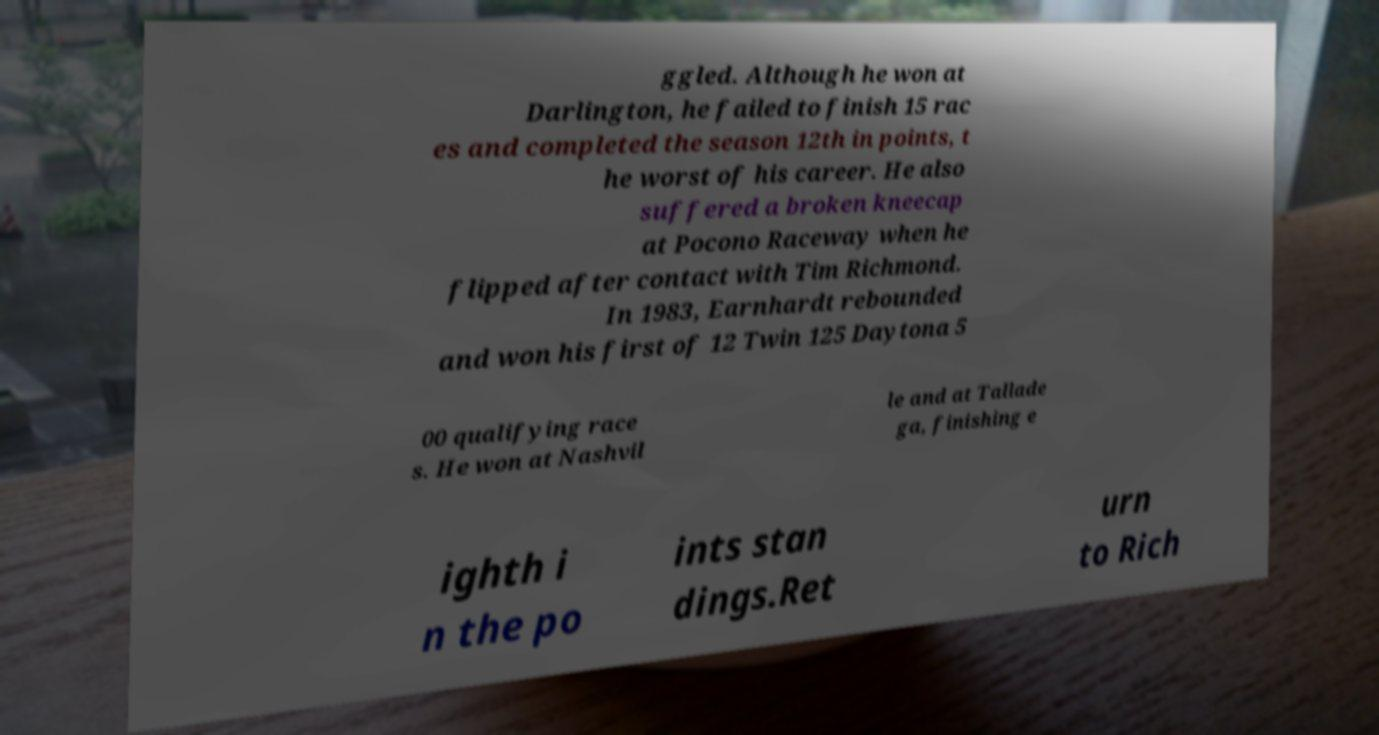I need the written content from this picture converted into text. Can you do that? ggled. Although he won at Darlington, he failed to finish 15 rac es and completed the season 12th in points, t he worst of his career. He also suffered a broken kneecap at Pocono Raceway when he flipped after contact with Tim Richmond. In 1983, Earnhardt rebounded and won his first of 12 Twin 125 Daytona 5 00 qualifying race s. He won at Nashvil le and at Tallade ga, finishing e ighth i n the po ints stan dings.Ret urn to Rich 